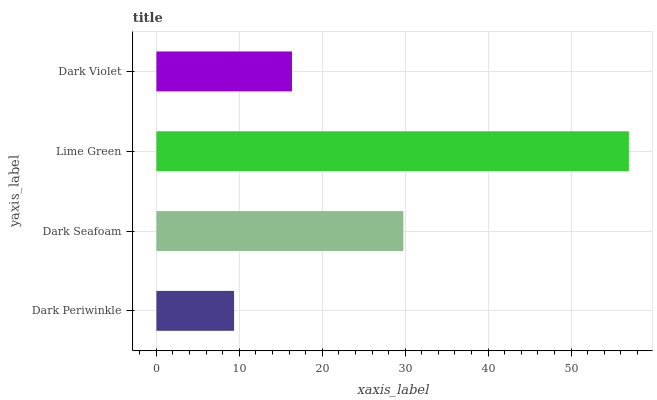Is Dark Periwinkle the minimum?
Answer yes or no. Yes. Is Lime Green the maximum?
Answer yes or no. Yes. Is Dark Seafoam the minimum?
Answer yes or no. No. Is Dark Seafoam the maximum?
Answer yes or no. No. Is Dark Seafoam greater than Dark Periwinkle?
Answer yes or no. Yes. Is Dark Periwinkle less than Dark Seafoam?
Answer yes or no. Yes. Is Dark Periwinkle greater than Dark Seafoam?
Answer yes or no. No. Is Dark Seafoam less than Dark Periwinkle?
Answer yes or no. No. Is Dark Seafoam the high median?
Answer yes or no. Yes. Is Dark Violet the low median?
Answer yes or no. Yes. Is Lime Green the high median?
Answer yes or no. No. Is Dark Periwinkle the low median?
Answer yes or no. No. 